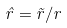Convert formula to latex. <formula><loc_0><loc_0><loc_500><loc_500>\hat { r } = \vec { r } / r</formula> 